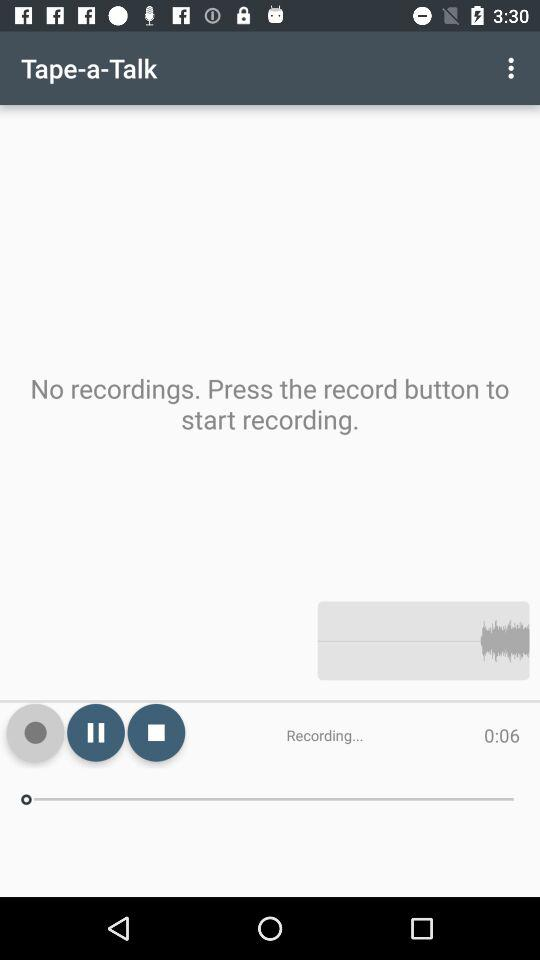How much audio has been recorded? There are 6 seconds of audio that have been recorded. 